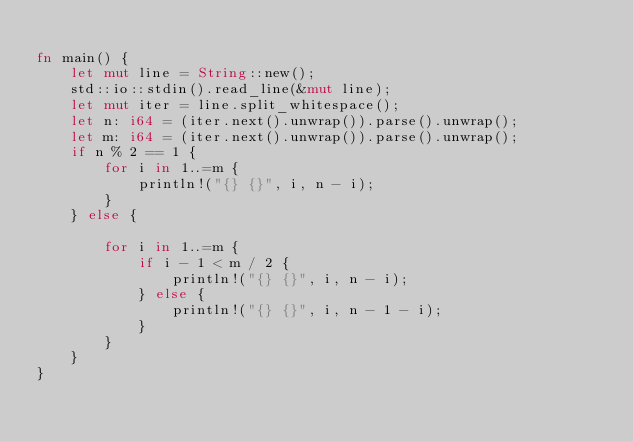Convert code to text. <code><loc_0><loc_0><loc_500><loc_500><_Rust_>
fn main() {
    let mut line = String::new();
    std::io::stdin().read_line(&mut line);
    let mut iter = line.split_whitespace();
    let n: i64 = (iter.next().unwrap()).parse().unwrap();
    let m: i64 = (iter.next().unwrap()).parse().unwrap();
    if n % 2 == 1 {
        for i in 1..=m {
            println!("{} {}", i, n - i);
        }
    } else {

        for i in 1..=m {
            if i - 1 < m / 2 {
                println!("{} {}", i, n - i);
            } else {
                println!("{} {}", i, n - 1 - i);
            }
        }
    }
}
</code> 